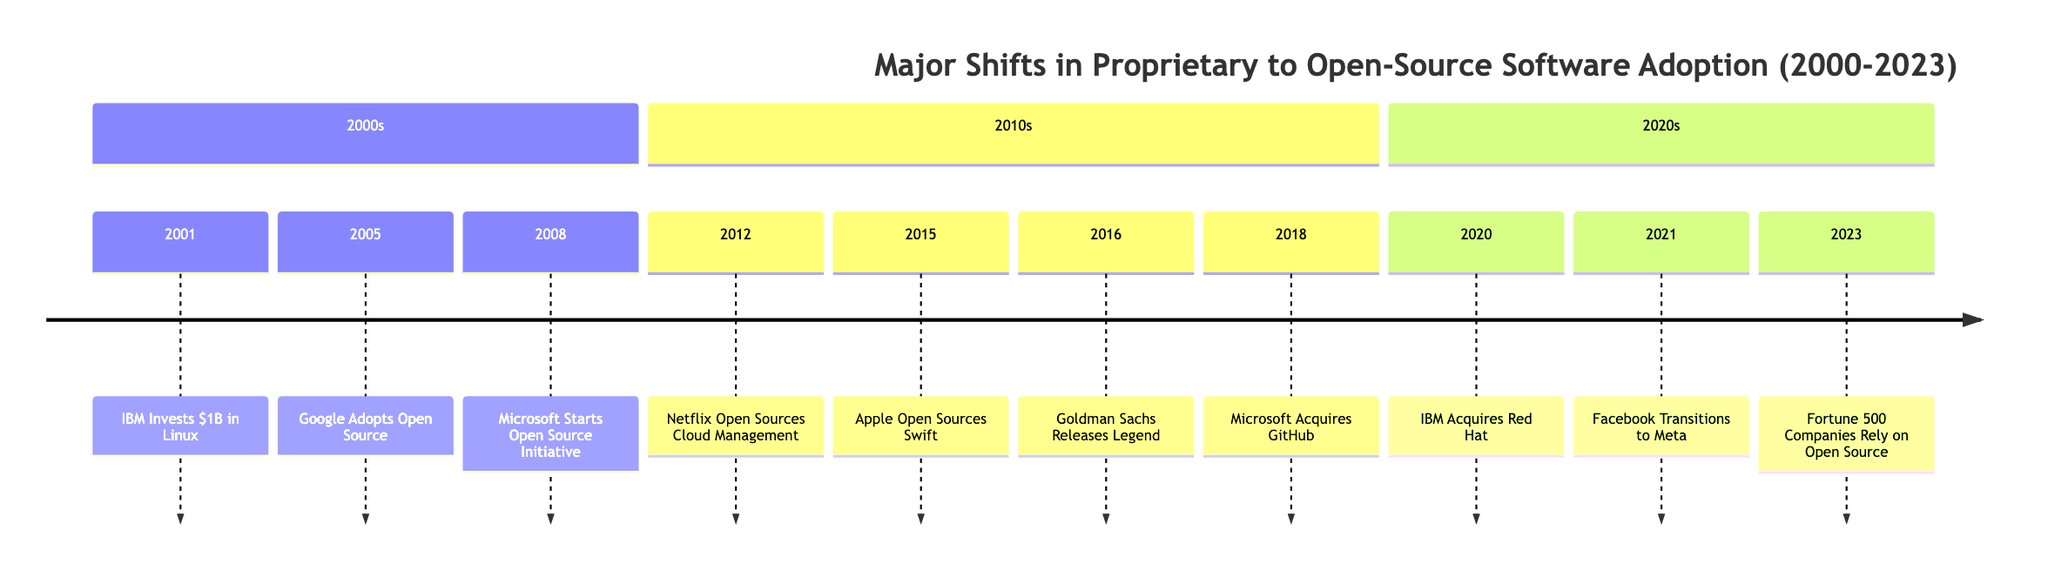What year did IBM invest $1 billion in Linux? The timeline shows that IBM made this investment in 2001.
Answer: 2001 Which Fortune 500 company open-sourced its cloud management software in 2012? According to the timeline, Netflix was the company that took this action in 2012.
Answer: Netflix What major event related to open-source software occurred in 2018? The timeline notes that Microsoft acquired GitHub in 2018, signifying a major development in the open-source landscape.
Answer: Microsoft Acquires GitHub How many events are documented in the timeline up to 2023? The timeline contains a total of 10 significant events related to the shift from proprietary to open-source software.
Answer: 10 Which company announced the open-sourcing of the Swift programming language? The timeline specifies that Apple was the company that announced the open-sourcing of Swift in 2015.
Answer: Apple What shift occurred in Fortune 500 companies by 2023? By 2023, the timeline indicates that Fortune 500 companies heavily relied on open-source software as part of their tech infrastructure.
Answer: Rely on open source Which two major acquisitions reflect the changing stance on open source from 2018 to 2020? Reviewing the timeline, Microsoft’s acquisition of GitHub in 2018 and IBM's acquisition of Red Hat in 2020 are the two major acquisitions reflecting this shift.
Answer: Microsoft Acquires GitHub, IBM Acquires Red Hat What initiative did Microsoft start in 2008? The timeline highlights that in 2008, Microsoft started an open-source initiative, marking a significant shift in its approach.
Answer: Microsoft Starts Open Source Initiative In what year did Goldman Sachs embrace open source with Legend? The timeline indicates that Goldman Sachs embraced open source by releasing Legend in 2016.
Answer: 2016 